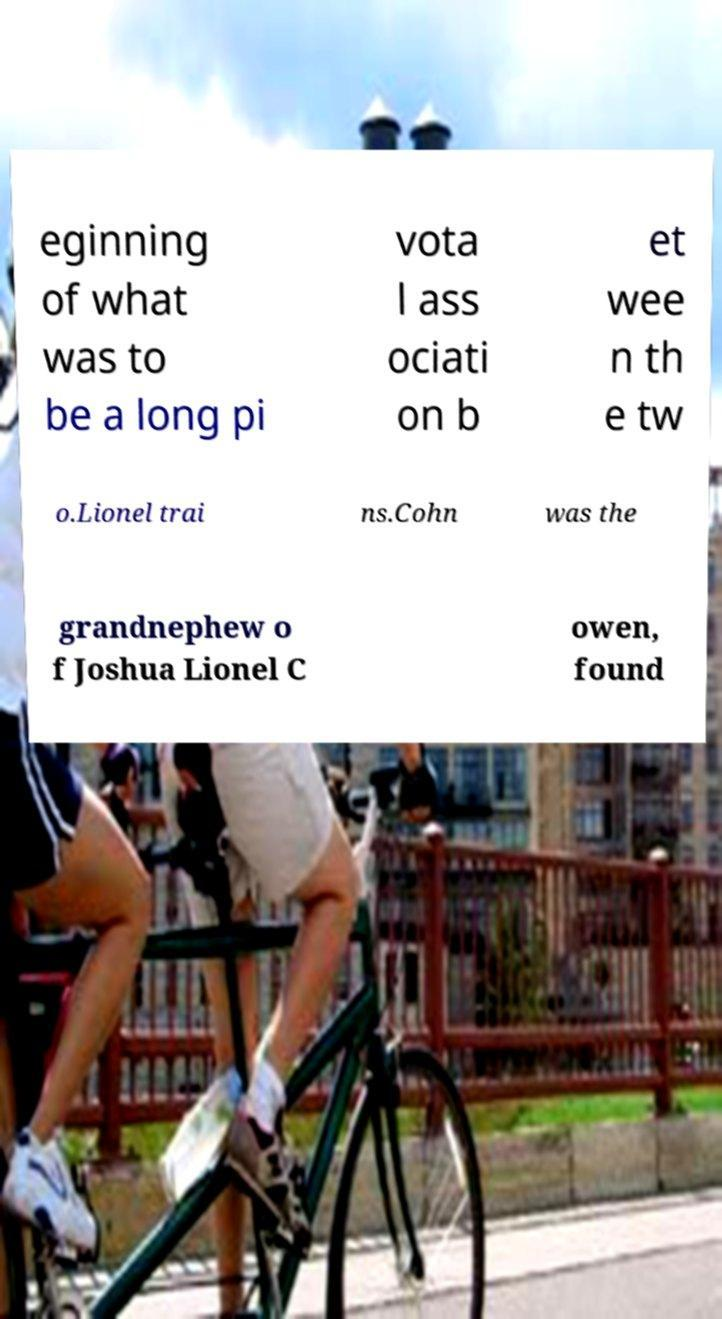Could you assist in decoding the text presented in this image and type it out clearly? eginning of what was to be a long pi vota l ass ociati on b et wee n th e tw o.Lionel trai ns.Cohn was the grandnephew o f Joshua Lionel C owen, found 